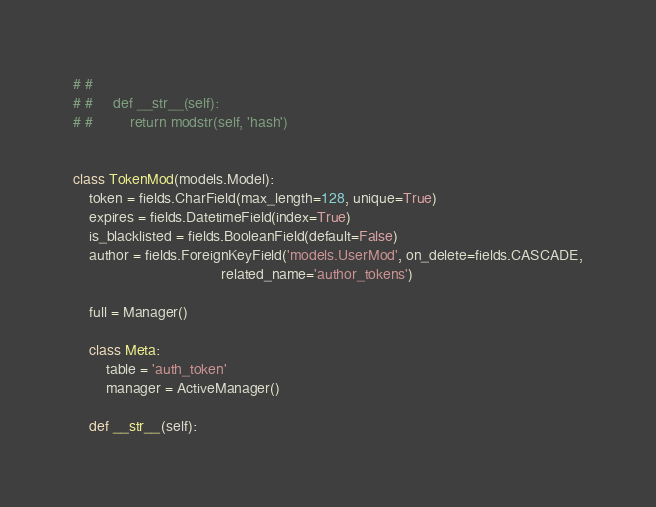Convert code to text. <code><loc_0><loc_0><loc_500><loc_500><_Python_># #
# #     def __str__(self):
# #         return modstr(self, 'hash')


class TokenMod(models.Model):
    token = fields.CharField(max_length=128, unique=True)
    expires = fields.DatetimeField(index=True)
    is_blacklisted = fields.BooleanField(default=False)
    author = fields.ForeignKeyField('models.UserMod', on_delete=fields.CASCADE,
                                    related_name='author_tokens')

    full = Manager()

    class Meta:
        table = 'auth_token'
        manager = ActiveManager()

    def __str__(self):</code> 